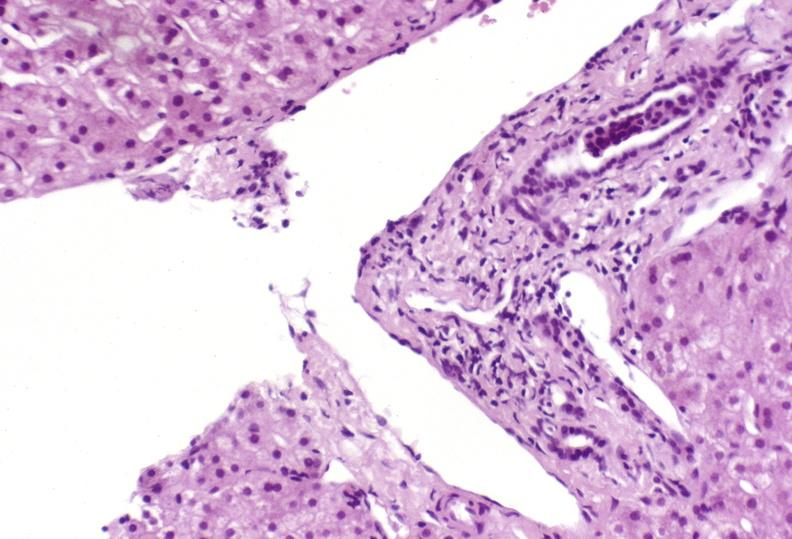what does this image show?
Answer the question using a single word or phrase. Mild acute rejection 